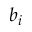<formula> <loc_0><loc_0><loc_500><loc_500>b _ { i }</formula> 